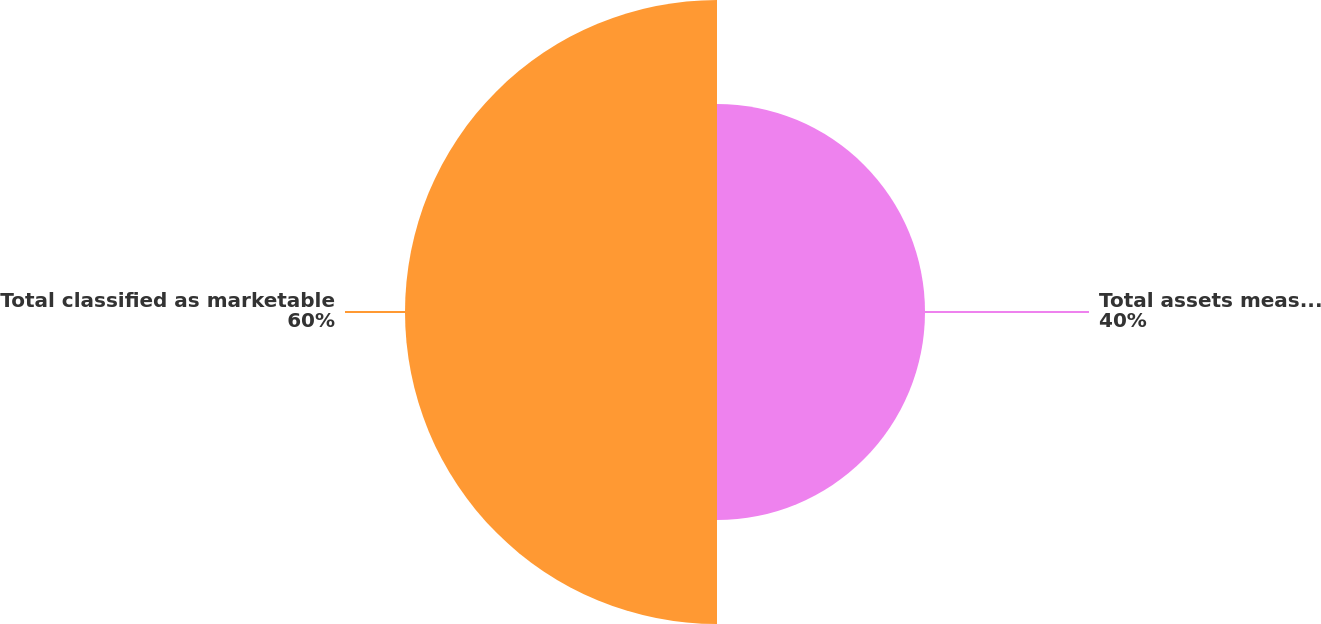Convert chart. <chart><loc_0><loc_0><loc_500><loc_500><pie_chart><fcel>Total assets measured at fair<fcel>Total classified as marketable<nl><fcel>40.0%<fcel>60.0%<nl></chart> 